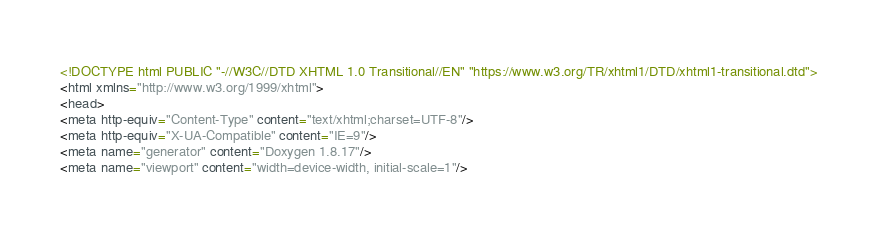<code> <loc_0><loc_0><loc_500><loc_500><_HTML_><!DOCTYPE html PUBLIC "-//W3C//DTD XHTML 1.0 Transitional//EN" "https://www.w3.org/TR/xhtml1/DTD/xhtml1-transitional.dtd">
<html xmlns="http://www.w3.org/1999/xhtml">
<head>
<meta http-equiv="Content-Type" content="text/xhtml;charset=UTF-8"/>
<meta http-equiv="X-UA-Compatible" content="IE=9"/>
<meta name="generator" content="Doxygen 1.8.17"/>
<meta name="viewport" content="width=device-width, initial-scale=1"/></code> 